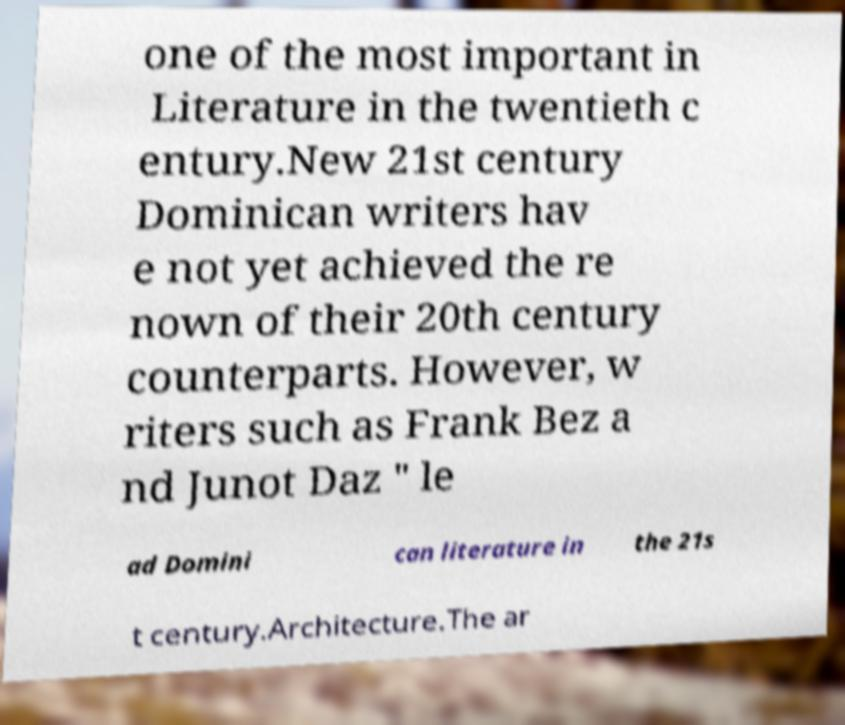Could you extract and type out the text from this image? one of the most important in Literature in the twentieth c entury.New 21st century Dominican writers hav e not yet achieved the re nown of their 20th century counterparts. However, w riters such as Frank Bez a nd Junot Daz " le ad Domini can literature in the 21s t century.Architecture.The ar 